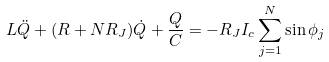Convert formula to latex. <formula><loc_0><loc_0><loc_500><loc_500>L \ddot { Q } + ( R + N R _ { J } ) \dot { Q } + \frac { Q } { C } = - R _ { J } I _ { c } \sum _ { j = 1 } ^ { N } \sin \phi _ { j }</formula> 